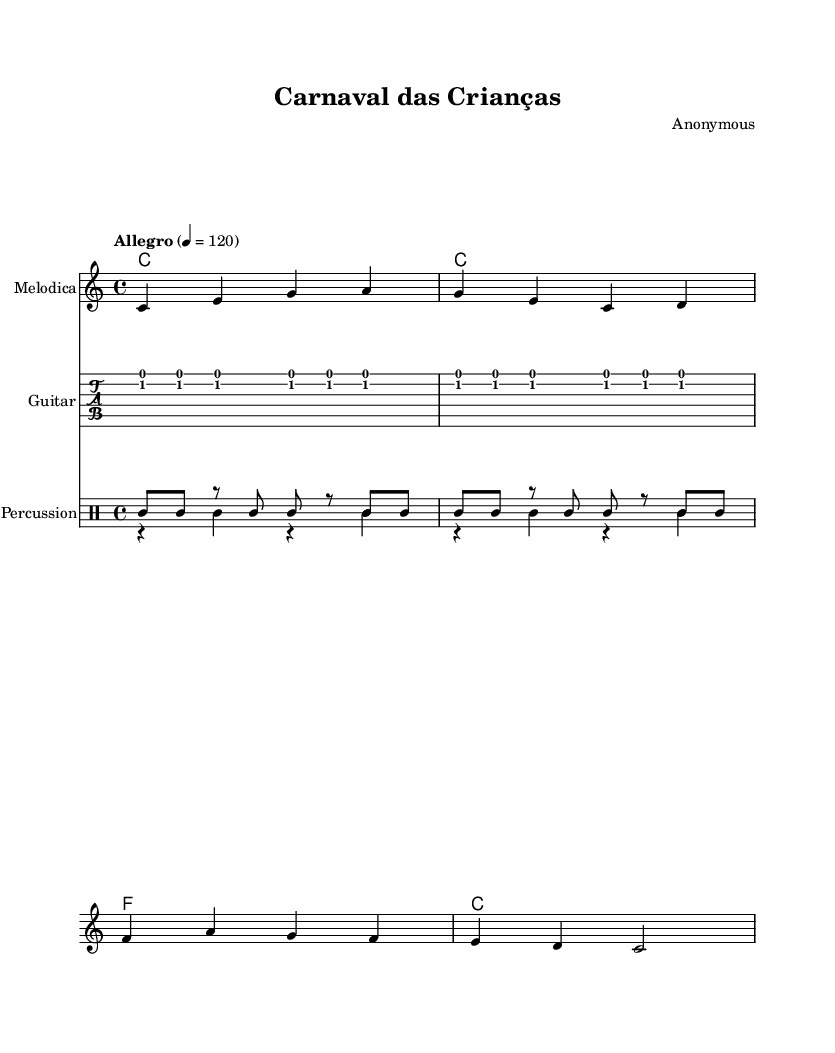What is the key signature of this music? The key signature is indicated by the absence of any sharps or flats, and it is labeled before the notes begin. This means it is in the key of C major.
Answer: C major What is the time signature of this piece? The time signature is shown at the beginning of the score, indicating how many beats are in each measure. In this case, it is 4/4, which means there are four beats in a measure.
Answer: 4/4 What is the tempo marking of the song? The tempo is indicated in the score as "Allegro," followed by a metronome marking of 120. "Allegro" generally means fast, and the metronome marking specifies the exact speed at which to play the piece.
Answer: Allegro 4 = 120 Which instruments are included in this score? The score labels different staves for each instrument. Here, we see a staff for "Melodica," a "Guitar" TabStaff, and a "Percussion" DrumStaff featuring pandeiro and triangle.
Answer: Melodica, Guitar, Percussion How many measures are present in the melody section? By counting the segmented bars in the melody line, there are 8 measures present. Each measure is separated by a vertical line in the music.
Answer: 8 Which rhythmic patterns are used in the percussion section? The percussion section features a pattern for the pandeiro and triangle. The pandeiro plays a repeating pattern and the triangle plays a contrasting rhythm with rests between hits. This layering creates a lively folk sound typical in South American carnival celebrations.
Answer: Pandeiro pattern, Triangle pattern What overall mood does this piece convey? The combination of an upbeat tempo, lively rhythm patterns, and cheerful melodic lines suggests an overall festive and joyful mood, typical for children's music and carnival celebrations.
Answer: Festive 